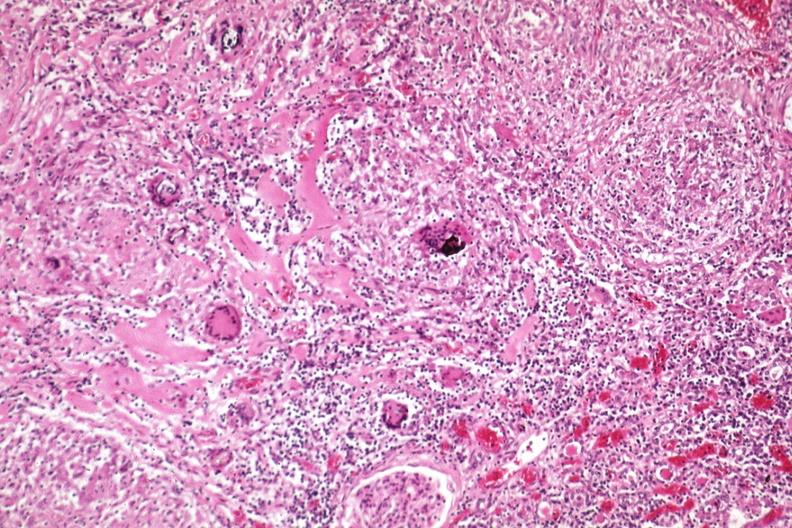s kidney present?
Answer the question using a single word or phrase. Yes 